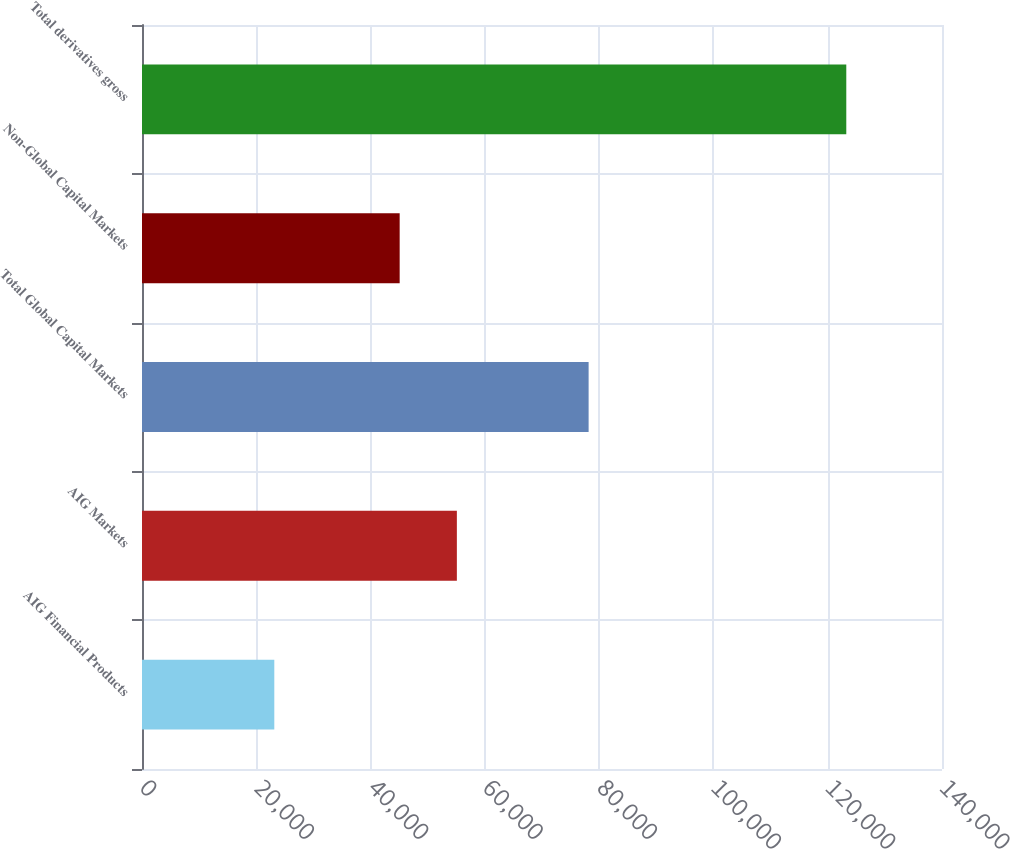Convert chart to OTSL. <chart><loc_0><loc_0><loc_500><loc_500><bar_chart><fcel>AIG Financial Products<fcel>AIG Markets<fcel>Total Global Capital Markets<fcel>Non-Global Capital Markets<fcel>Total derivatives gross<nl><fcel>23153<fcel>55101.7<fcel>78158<fcel>45092<fcel>123250<nl></chart> 